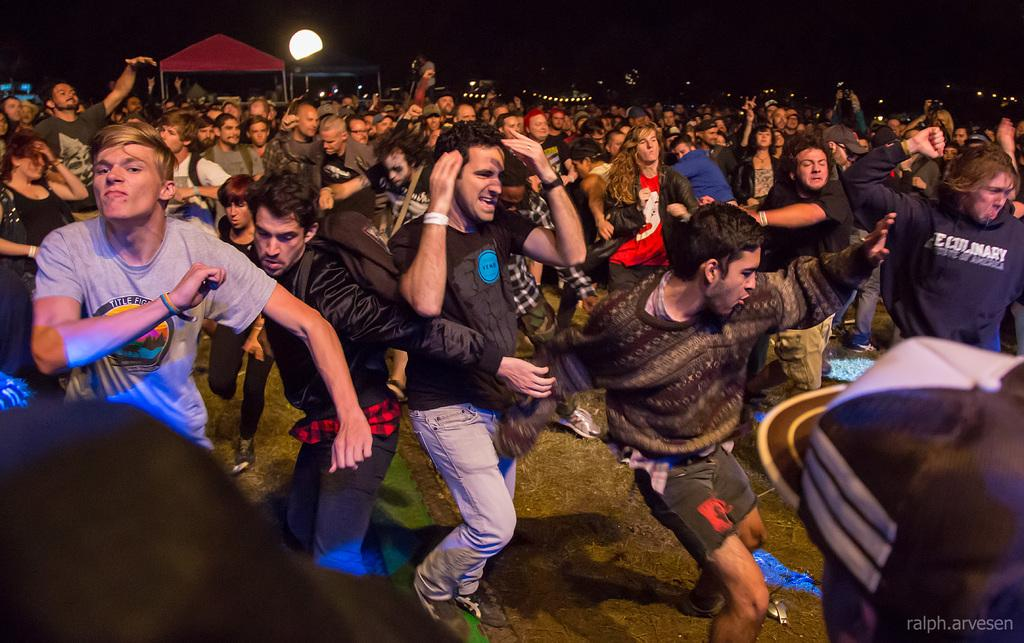How many people are in the image? There is a group of persons in the image. What are the persons in the image doing? The persons are dancing. Where is the dancing taking place? The dancing is taking place in an open area. What can be seen in the background of the image? There are huts and lights visible in the background of the image. What type of wall can be seen in the image? There is no wall present in the image. What impulse caused the persons to start dancing in the image? The image does not provide information about the impulse that caused the persons to start dancing. 